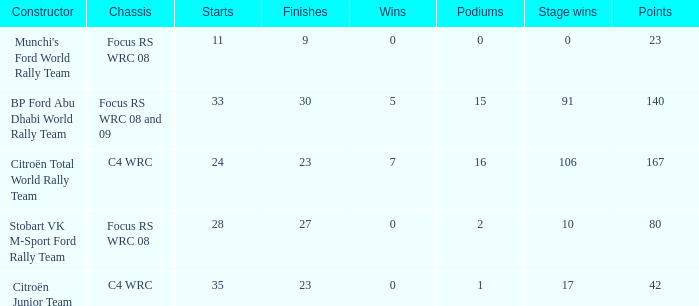What is the highest points when the chassis is focus rs wrc 08 and 09 and the stage wins is more than 91? None. 